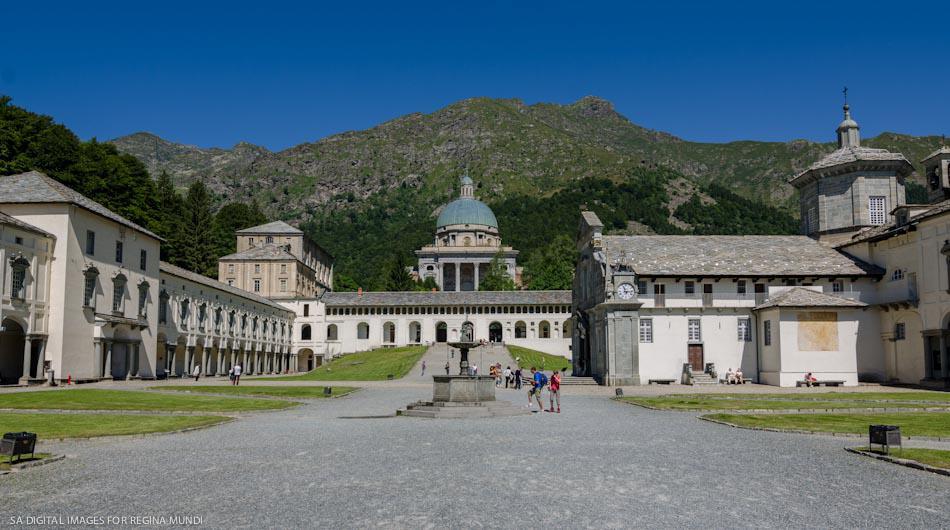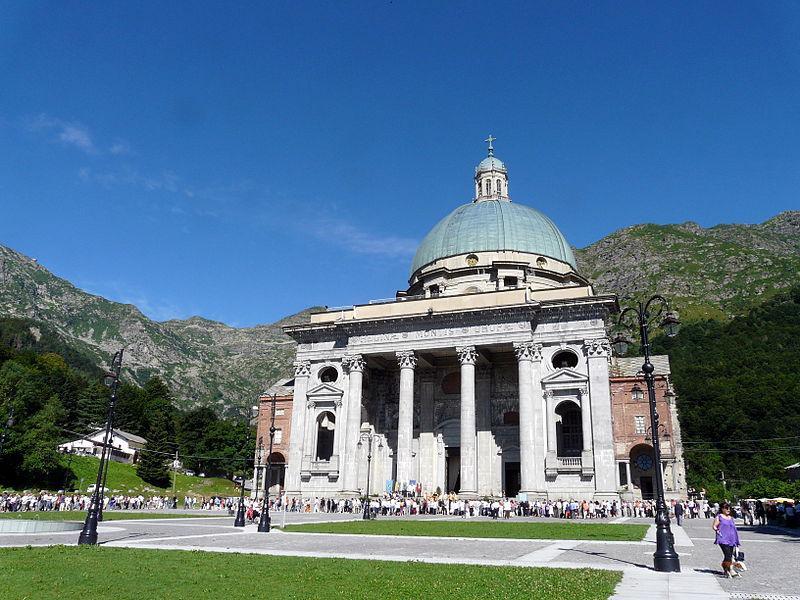The first image is the image on the left, the second image is the image on the right. Analyze the images presented: Is the assertion "There is a building with a blue dome in at least one of the images." valid? Answer yes or no. Yes. 